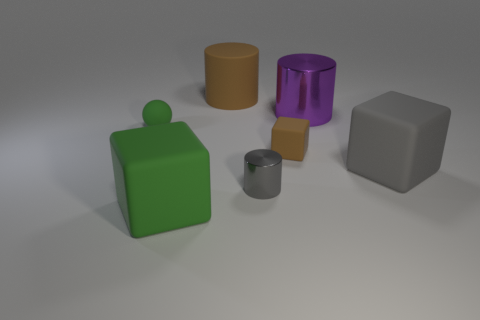How many purple things are either large cylinders or small shiny cylinders?
Your answer should be very brief. 1. Do the shiny thing behind the tiny green rubber sphere and the rubber cube that is in front of the tiny cylinder have the same size?
Offer a very short reply. Yes. What number of objects are tiny gray things or big gray things?
Make the answer very short. 2. Are there any other gray matte things of the same shape as the large gray rubber object?
Keep it short and to the point. No. Is the number of big cyan shiny cylinders less than the number of small metallic cylinders?
Ensure brevity in your answer.  Yes. Does the small gray thing have the same shape as the large gray thing?
Make the answer very short. No. How many objects are tiny cyan metal things or brown matte blocks that are behind the small shiny object?
Your answer should be very brief. 1. How many tiny brown blocks are there?
Make the answer very short. 1. Is there a thing of the same size as the gray metal cylinder?
Your response must be concise. Yes. Are there fewer large purple cylinders in front of the brown cube than large yellow metal spheres?
Keep it short and to the point. No. 